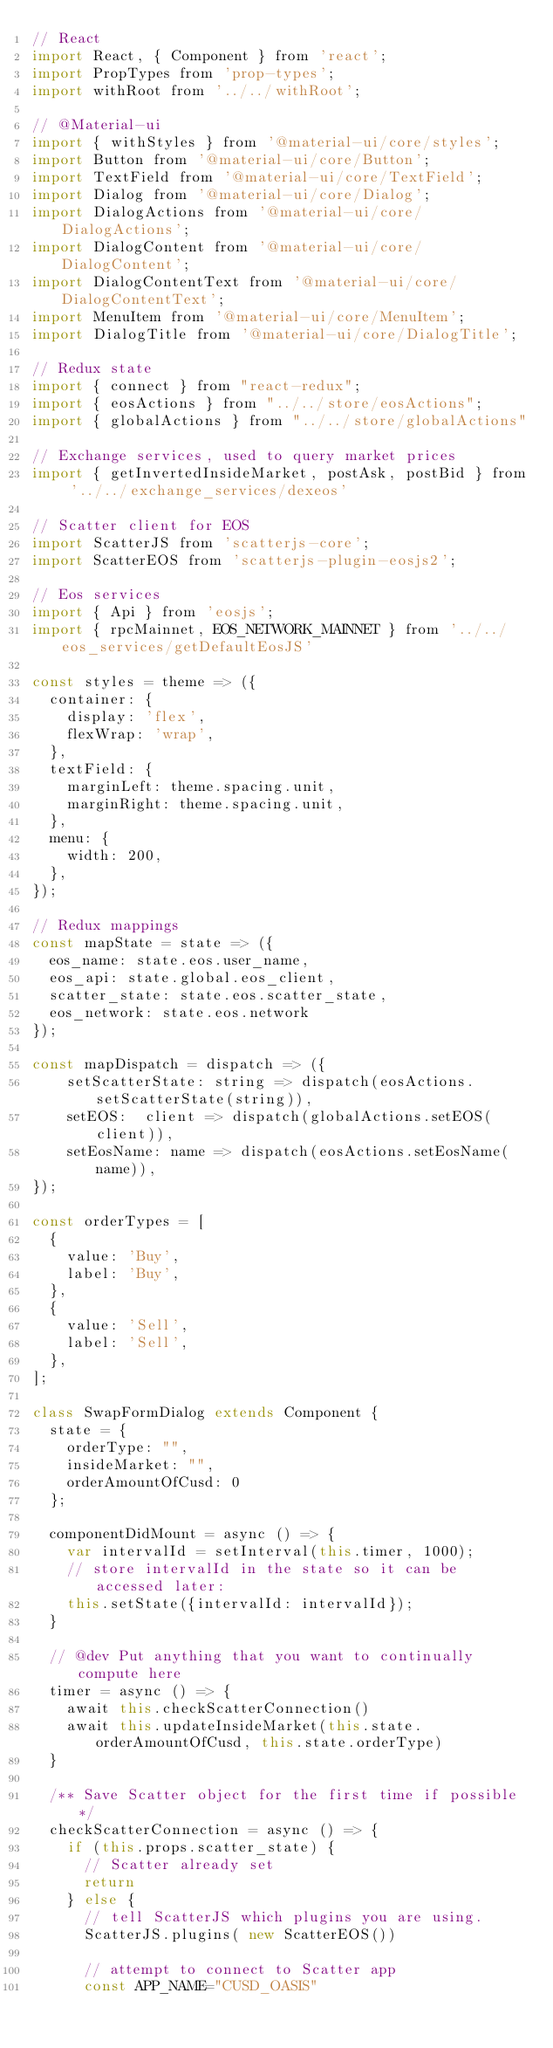<code> <loc_0><loc_0><loc_500><loc_500><_JavaScript_>// React
import React, { Component } from 'react';
import PropTypes from 'prop-types';
import withRoot from '../../withRoot';

// @Material-ui
import { withStyles } from '@material-ui/core/styles';
import Button from '@material-ui/core/Button';
import TextField from '@material-ui/core/TextField';
import Dialog from '@material-ui/core/Dialog';
import DialogActions from '@material-ui/core/DialogActions';
import DialogContent from '@material-ui/core/DialogContent';
import DialogContentText from '@material-ui/core/DialogContentText';
import MenuItem from '@material-ui/core/MenuItem';
import DialogTitle from '@material-ui/core/DialogTitle';

// Redux state
import { connect } from "react-redux";
import { eosActions } from "../../store/eosActions";
import { globalActions } from "../../store/globalActions"

// Exchange services, used to query market prices
import { getInvertedInsideMarket, postAsk, postBid } from '../../exchange_services/dexeos'

// Scatter client for EOS
import ScatterJS from 'scatterjs-core';
import ScatterEOS from 'scatterjs-plugin-eosjs2';

// Eos services
import { Api } from 'eosjs';
import { rpcMainnet, EOS_NETWORK_MAINNET } from '../../eos_services/getDefaultEosJS'

const styles = theme => ({
  container: {
    display: 'flex',
    flexWrap: 'wrap',
  },
  textField: {
    marginLeft: theme.spacing.unit,
    marginRight: theme.spacing.unit,
  },
  menu: {
    width: 200,
  },
});

// Redux mappings
const mapState = state => ({
  eos_name: state.eos.user_name,
  eos_api: state.global.eos_client,
  scatter_state: state.eos.scatter_state,
  eos_network: state.eos.network
});

const mapDispatch = dispatch => ({
    setScatterState: string => dispatch(eosActions.setScatterState(string)),
    setEOS:  client => dispatch(globalActions.setEOS(client)),
    setEosName: name => dispatch(eosActions.setEosName(name)),
});

const orderTypes = [
  {
    value: 'Buy',
    label: 'Buy',
  },
  {
    value: 'Sell',
    label: 'Sell',
  },
];

class SwapFormDialog extends Component {
  state = {
    orderType: "",
    insideMarket: "",
    orderAmountOfCusd: 0
  };

  componentDidMount = async () => {
    var intervalId = setInterval(this.timer, 1000);
    // store intervalId in the state so it can be accessed later:
    this.setState({intervalId: intervalId});
  }

  // @dev Put anything that you want to continually compute here
  timer = async () => {
    await this.checkScatterConnection()
    await this.updateInsideMarket(this.state.orderAmountOfCusd, this.state.orderType)
  }
  
  /** Save Scatter object for the first time if possible */
  checkScatterConnection = async () => {
    if (this.props.scatter_state) {
      // Scatter already set
      return
    } else {
      // tell ScatterJS which plugins you are using.
      ScatterJS.plugins( new ScatterEOS())

      // attempt to connect to Scatter app
      const APP_NAME="CUSD_OASIS"</code> 